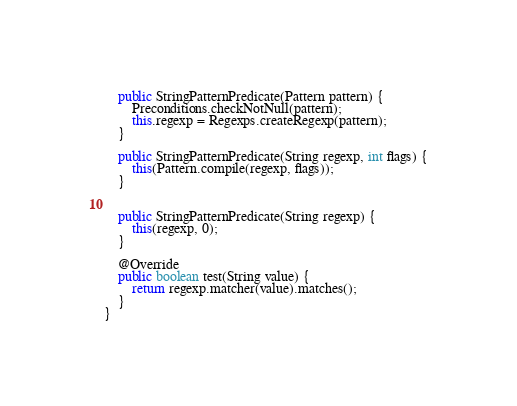Convert code to text. <code><loc_0><loc_0><loc_500><loc_500><_Java_>
    public StringPatternPredicate(Pattern pattern) {
        Preconditions.checkNotNull(pattern);
        this.regexp = Regexps.createRegexp(pattern);
    }

    public StringPatternPredicate(String regexp, int flags) {
        this(Pattern.compile(regexp, flags));
    }


    public StringPatternPredicate(String regexp) {
        this(regexp, 0);
    }

    @Override
    public boolean test(String value) {
        return regexp.matcher(value).matches();
    }
}
</code> 